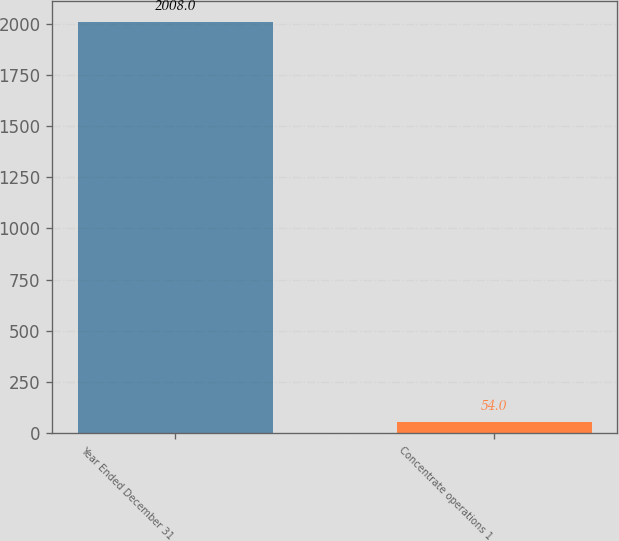<chart> <loc_0><loc_0><loc_500><loc_500><bar_chart><fcel>Year Ended December 31<fcel>Concentrate operations 1<nl><fcel>2008<fcel>54<nl></chart> 